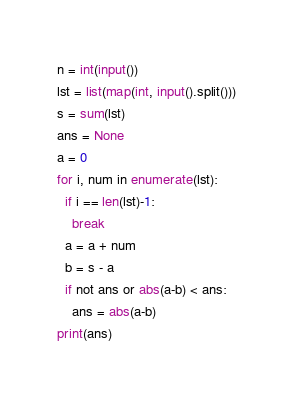<code> <loc_0><loc_0><loc_500><loc_500><_Python_>n = int(input())
lst = list(map(int, input().split()))
s = sum(lst)
ans = None
a = 0
for i, num in enumerate(lst):
  if i == len(lst)-1:
    break
  a = a + num
  b = s - a
  if not ans or abs(a-b) < ans:
    ans = abs(a-b)
print(ans)</code> 